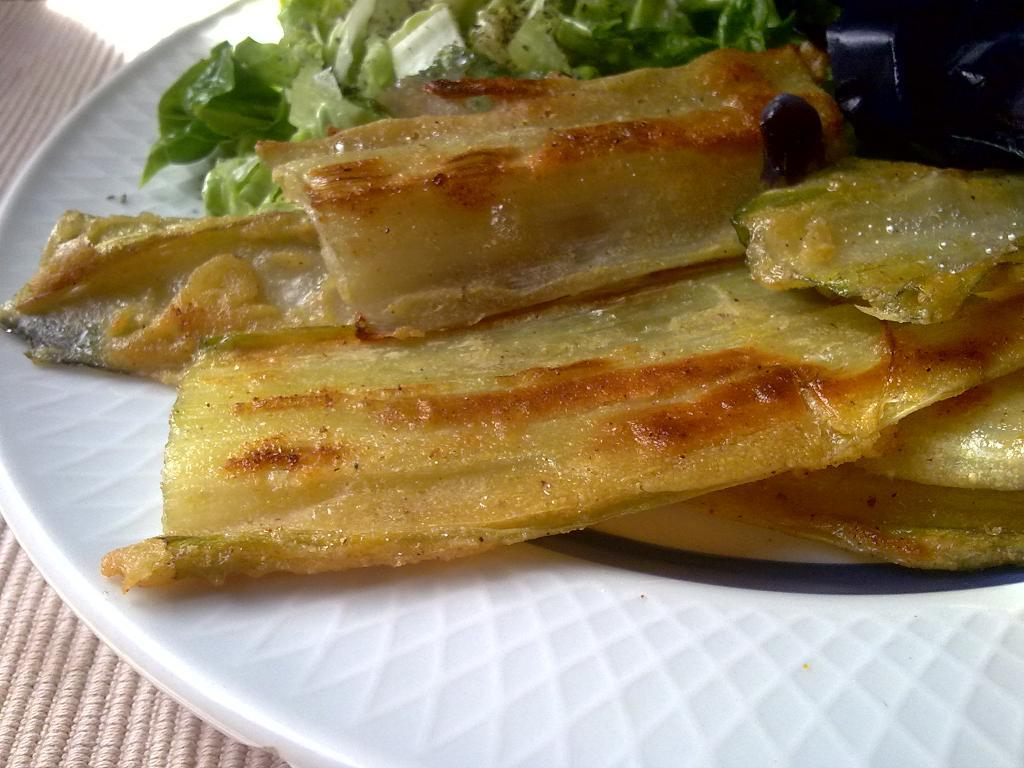What is the main object in the center of the image? There is a plate in the center of the image. What is on the plate? The plate contains food items. What type of iron is being used to cook the food on the plate? There is no iron or cooking activity visible in the image; it only shows a plate with food items. 